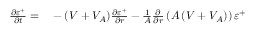<formula> <loc_0><loc_0><loc_500><loc_500>\begin{array} { r l } { \frac { \partial \varepsilon ^ { + } } { \partial t } = } & - ( V + V _ { A } ) \frac { \partial \varepsilon ^ { + } } { \partial r } - \frac { 1 } { A } \frac { \partial } { \partial r } \left ( A \left ( V + V _ { A } \right ) \right ) \varepsilon ^ { + } } \end{array}</formula> 